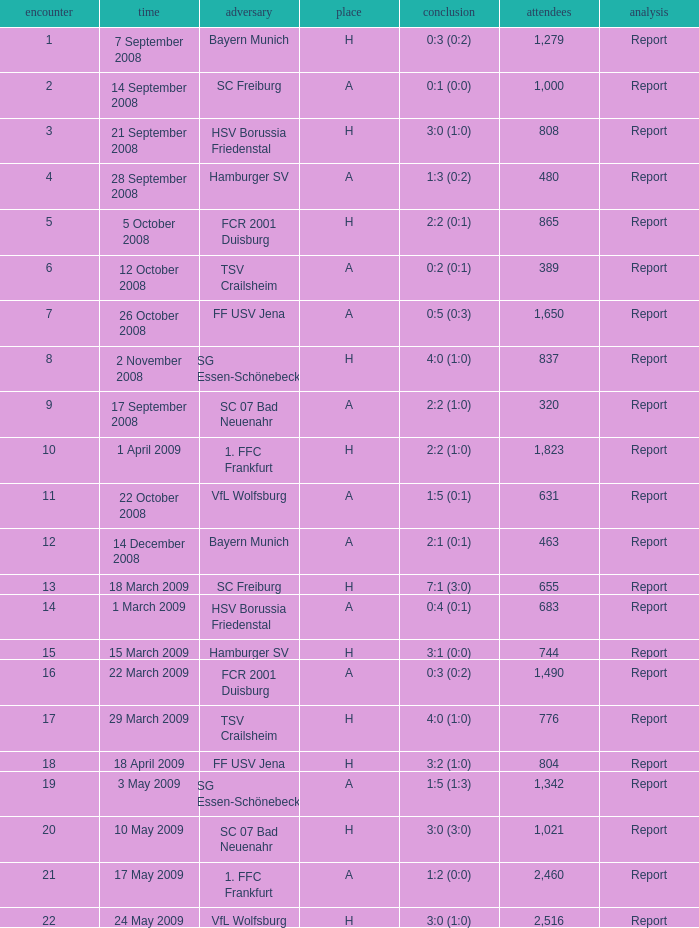Which match had more than 1,490 people in attendance to watch FCR 2001 Duisburg have a result of 0:3 (0:2)? None. 